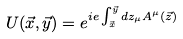Convert formula to latex. <formula><loc_0><loc_0><loc_500><loc_500>U ( \vec { x } , \vec { y } ) = e ^ { i e \int _ { \vec { x } } ^ { \vec { y } } d z _ { \mu } A ^ { \mu } ( \vec { z } ) }</formula> 